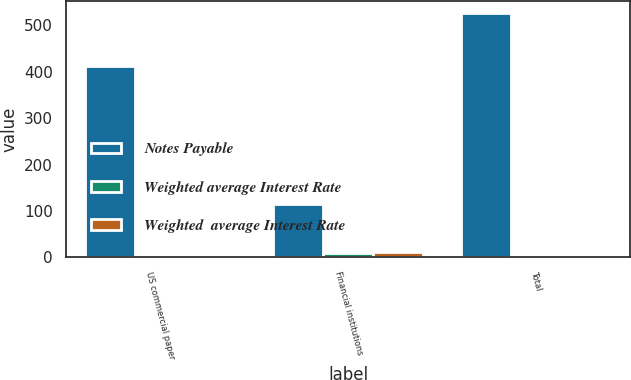Convert chart to OTSL. <chart><loc_0><loc_0><loc_500><loc_500><stacked_bar_chart><ecel><fcel>US commercial paper<fcel>Financial institutions<fcel>Total<nl><fcel>Notes Payable<fcel>412<fcel>114.5<fcel>526.5<nl><fcel>Weighted average Interest Rate<fcel>0.2<fcel>10<fcel>2.4<nl><fcel>Weighted  average Interest Rate<fcel>0.2<fcel>11.5<fcel>4.5<nl></chart> 